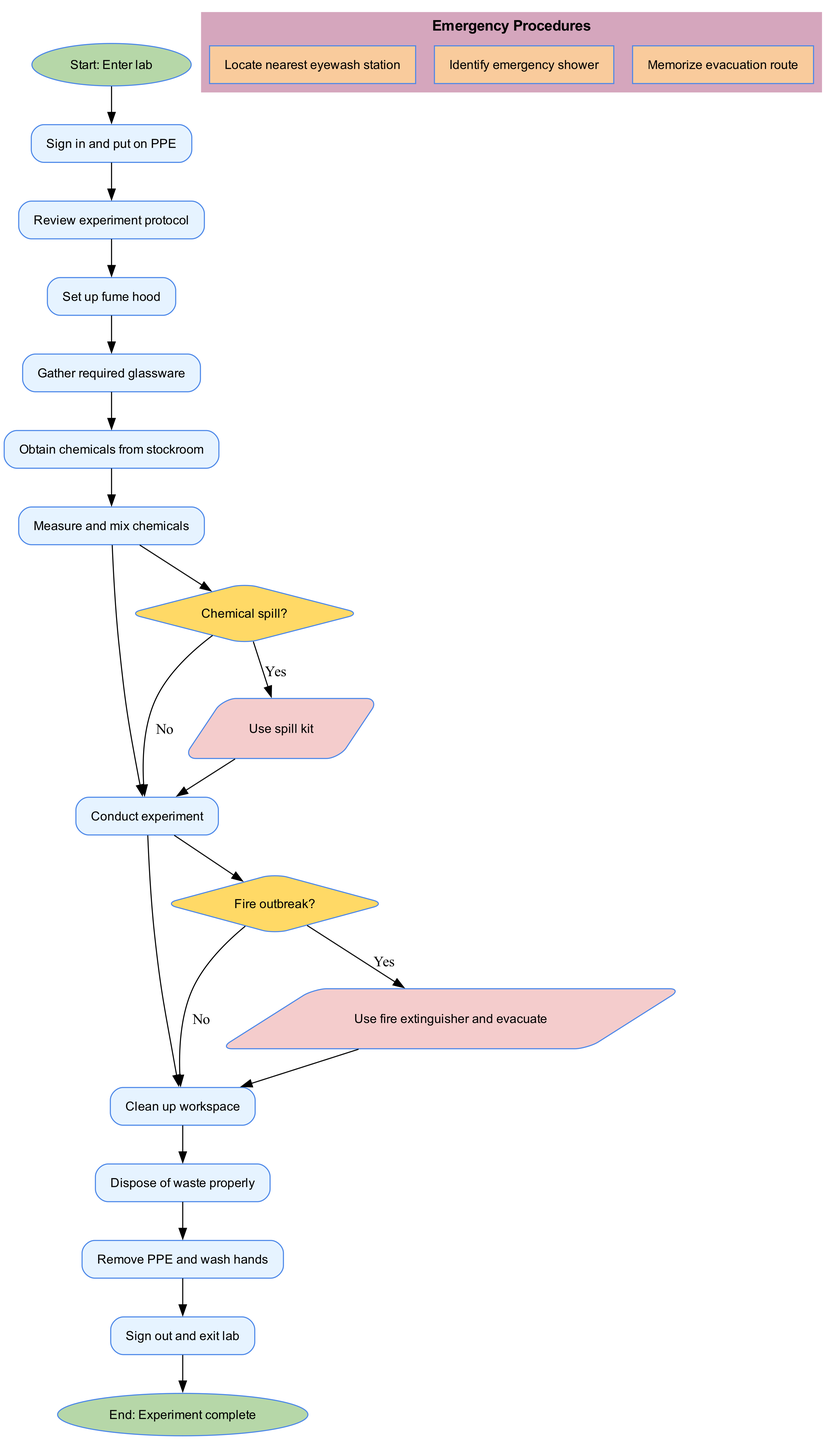What is the first activity listed in the diagram? The diagram begins with the "Enter lab" node as the starting point. From there, it leads to the first activity, which is "Sign in and put on PPE."
Answer: Sign in and put on PPE How many activities are present in the diagram? By counting the nodes representing activities, there are a total of ten activities, including the initial sign-in and final cleanup actions.
Answer: Ten Which decision point follows the activity "Measure and mix chemicals"? The activity "Measure and mix chemicals" is followed by the decision point regarding a "Chemical spill?" that asks whether a spill has occurred.
Answer: Chemical spill? What do you do if there is a fire outbreak? According to the diagram, if there is a fire outbreak, the correct action is to "Use fire extinguisher and evacuate."
Answer: Use fire extinguisher and evacuate What are the emergency procedures listed in the diagram? The diagram outlines three emergency procedures: "Locate nearest eyewash station," "Identify emergency shower," and "Memorize evacuation route."
Answer: Locate nearest eyewash station, Identify emergency shower, Memorize evacuation route Is "Clean up workspace" before or after "Conduct experiment"? Based on the flow of the diagram, "Clean up workspace" is the last activity that follows "Conduct experiment." Thus, it occurs after conducting the experiment.
Answer: After How many decision points are included in the diagram? The diagram includes two decision points: one about a chemical spill and another about a fire outbreak.
Answer: Two What happens after selecting "Yes" for the "Chemical spill?" decision? Choosing "Yes" for the "Chemical spill?" decision leads to the action "Use spill kit," which allows the experiment to continue after addressing the spill.
Answer: Use spill kit What is the final node in the flow of the diagram? The flow of the diagram concludes with the final node labeled "Experiment complete," which indicates the end of the process.
Answer: Experiment complete 